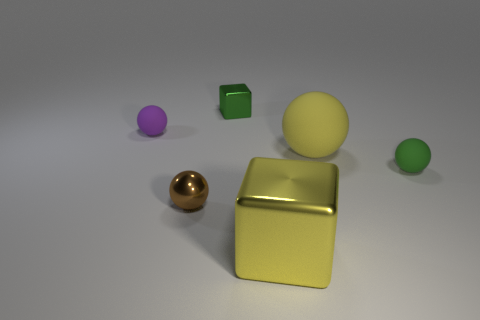Subtract all brown metallic balls. How many balls are left? 3 Subtract all brown balls. How many balls are left? 3 Add 3 large matte cylinders. How many objects exist? 9 Subtract 1 balls. How many balls are left? 3 Subtract all red spheres. Subtract all blue cylinders. How many spheres are left? 4 Subtract all blocks. How many objects are left? 4 Add 5 yellow blocks. How many yellow blocks are left? 6 Add 1 purple rubber balls. How many purple rubber balls exist? 2 Subtract 0 blue cylinders. How many objects are left? 6 Subtract all tiny purple spheres. Subtract all spheres. How many objects are left? 1 